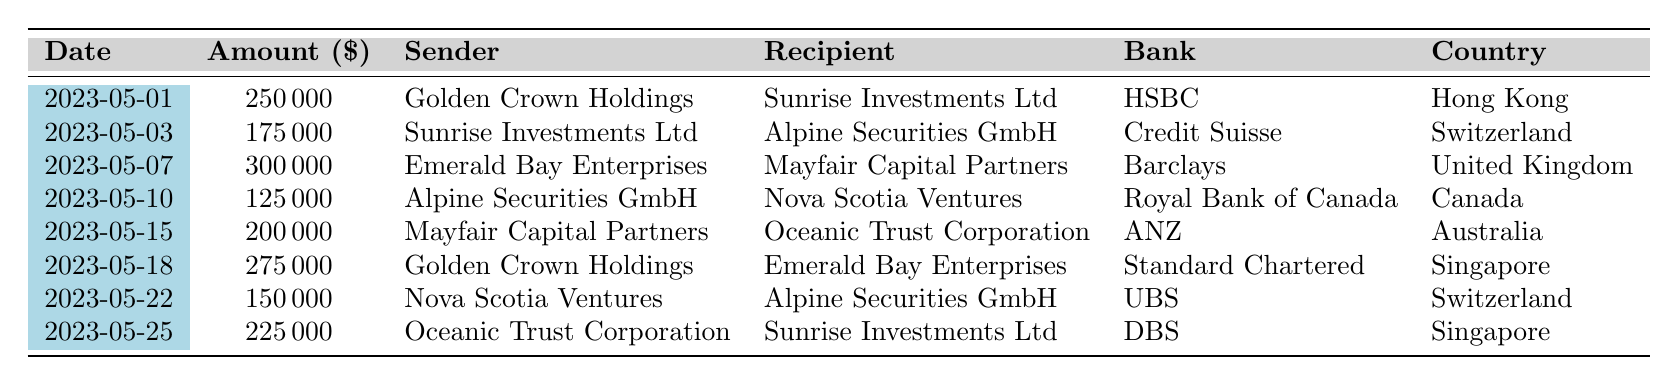What is the total amount of money sent by Golden Crown Holdings? There are two transactions involving Golden Crown Holdings: one for 250,000 and another for 275,000. By adding these amounts (250,000 + 275,000), the total is 525,000.
Answer: 525000 Which bank facilitated the smallest transaction? The transaction with the smallest amount is for 125,000 by Alpine Securities GmbH. This transaction was facilitated by the Royal Bank of Canada.
Answer: Royal Bank of Canada How many transactions were made in Switzerland? There are two transactions listed with recipients or senders in Switzerland: one from Sunrise Investments Ltd to Alpine Securities GmbH and another from Nova Scotia Ventures to Alpine Securities GmbH. Thus, the total is 2.
Answer: 2 What is the average transaction amount across all transactions? First, I need to sum the transaction amounts: 250,000 + 175,000 + 300,000 + 125,000 + 200,000 + 275,000 + 150,000 + 225,000 = 1,700,000. Then, since there are 8 transactions, I calculate the average by dividing the total by 8 (1,700,000 / 8) which equals 212,500.
Answer: 212500 Is there a transaction involving a recipient from both Hong Kong and Australia? There are no transactions listed where the recipients or senders are based in both Hong Kong and Australia simultaneously—in the table, all are from separate transactions.
Answer: No What is the cumulative amount of money transferred to Sunrise Investments Ltd? Sunrise Investments Ltd received two transactions: one from Golden Crown Holdings for 250,000 and one from Oceanic Trust Corporation for 225,000. Adding these amounts (250,000 + 225,000) gives a total of 475,000 transferred to Sunrise Investments Ltd.
Answer: 475000 Which country has the highest transaction amount? Looking at the transactions, the highest individual transaction amount is 300,000 from Emerald Bay Enterprises to Mayfair Capital Partners, which took place in the United Kingdom. Therefore, the country with the highest transaction amount is the United Kingdom.
Answer: United Kingdom How many different companies are involved as senders? There are five distinct senders listed: Golden Crown Holdings, Sunrise Investments Ltd, Emerald Bay Enterprises, Alpine Securities GmbH, and Mayfair Capital Partners. Thus, the count of different companies is 5.
Answer: 5 What is the total amount sent from Alpine Securities GmbH? Alpine Securities GmbH is involved in two transactions: it sent 125,000 to Nova Scotia Ventures and received 175,000 from Sunrise Investments Ltd, resulting in a net amount of 125,000 sent.
Answer: 125000 Which company had a transaction involving the most value as a recipient? The highest single transaction amount as a recipient is 300,000 received by Mayfair Capital Partners from Emerald Bay Enterprises.
Answer: Mayfair Capital Partners 